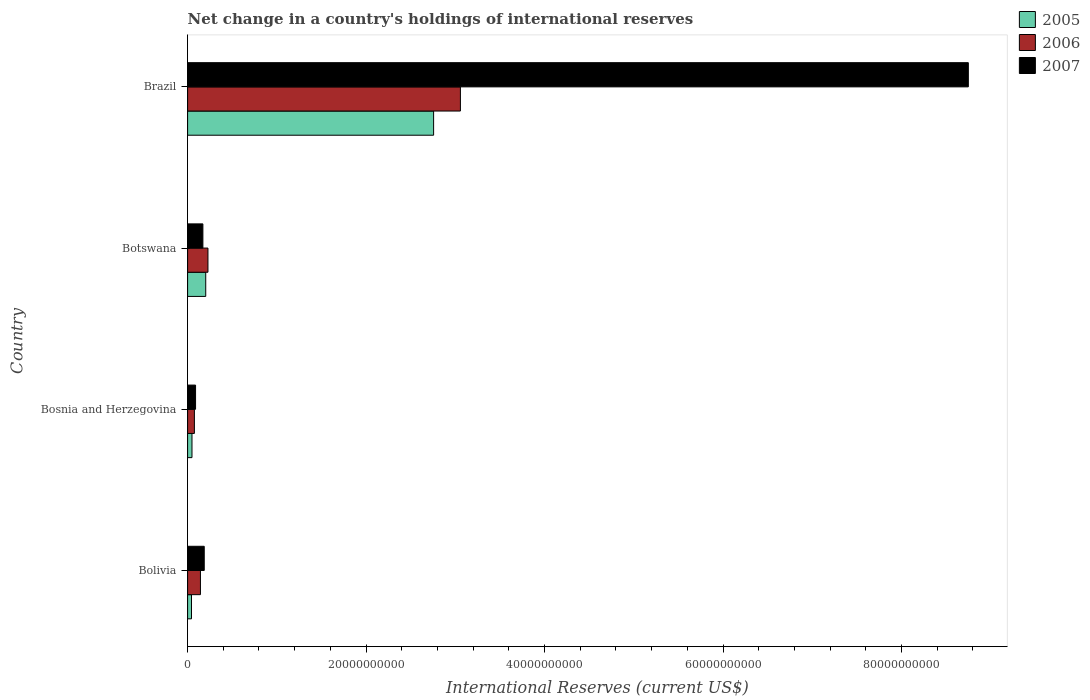How many different coloured bars are there?
Offer a terse response. 3. Are the number of bars per tick equal to the number of legend labels?
Offer a very short reply. Yes. How many bars are there on the 1st tick from the top?
Make the answer very short. 3. How many bars are there on the 2nd tick from the bottom?
Provide a short and direct response. 3. What is the label of the 4th group of bars from the top?
Provide a short and direct response. Bolivia. In how many cases, is the number of bars for a given country not equal to the number of legend labels?
Ensure brevity in your answer.  0. What is the international reserves in 2005 in Bolivia?
Offer a very short reply. 4.37e+08. Across all countries, what is the maximum international reserves in 2005?
Give a very brief answer. 2.76e+1. Across all countries, what is the minimum international reserves in 2006?
Give a very brief answer. 7.61e+08. In which country was the international reserves in 2007 minimum?
Your response must be concise. Bosnia and Herzegovina. What is the total international reserves in 2006 in the graph?
Provide a succinct answer. 3.51e+1. What is the difference between the international reserves in 2006 in Bolivia and that in Brazil?
Ensure brevity in your answer.  -2.91e+1. What is the difference between the international reserves in 2005 in Bolivia and the international reserves in 2007 in Brazil?
Your response must be concise. -8.70e+1. What is the average international reserves in 2007 per country?
Your answer should be very brief. 2.30e+1. What is the difference between the international reserves in 2006 and international reserves in 2007 in Botswana?
Make the answer very short. 5.67e+08. What is the ratio of the international reserves in 2007 in Bolivia to that in Botswana?
Ensure brevity in your answer.  1.09. What is the difference between the highest and the second highest international reserves in 2006?
Offer a very short reply. 2.83e+1. What is the difference between the highest and the lowest international reserves in 2006?
Your answer should be compact. 2.98e+1. In how many countries, is the international reserves in 2005 greater than the average international reserves in 2005 taken over all countries?
Make the answer very short. 1. Is it the case that in every country, the sum of the international reserves in 2005 and international reserves in 2007 is greater than the international reserves in 2006?
Offer a very short reply. Yes. How many bars are there?
Ensure brevity in your answer.  12. Does the graph contain grids?
Provide a succinct answer. No. Where does the legend appear in the graph?
Give a very brief answer. Top right. How many legend labels are there?
Provide a short and direct response. 3. What is the title of the graph?
Offer a very short reply. Net change in a country's holdings of international reserves. Does "2006" appear as one of the legend labels in the graph?
Ensure brevity in your answer.  Yes. What is the label or title of the X-axis?
Offer a very short reply. International Reserves (current US$). What is the International Reserves (current US$) in 2005 in Bolivia?
Keep it short and to the point. 4.37e+08. What is the International Reserves (current US$) in 2006 in Bolivia?
Make the answer very short. 1.44e+09. What is the International Reserves (current US$) of 2007 in Bolivia?
Provide a short and direct response. 1.87e+09. What is the International Reserves (current US$) in 2005 in Bosnia and Herzegovina?
Offer a very short reply. 4.91e+08. What is the International Reserves (current US$) in 2006 in Bosnia and Herzegovina?
Your answer should be very brief. 7.61e+08. What is the International Reserves (current US$) of 2007 in Bosnia and Herzegovina?
Provide a short and direct response. 8.92e+08. What is the International Reserves (current US$) in 2005 in Botswana?
Provide a short and direct response. 2.03e+09. What is the International Reserves (current US$) of 2006 in Botswana?
Give a very brief answer. 2.28e+09. What is the International Reserves (current US$) of 2007 in Botswana?
Keep it short and to the point. 1.71e+09. What is the International Reserves (current US$) of 2005 in Brazil?
Your response must be concise. 2.76e+1. What is the International Reserves (current US$) in 2006 in Brazil?
Offer a very short reply. 3.06e+1. What is the International Reserves (current US$) of 2007 in Brazil?
Keep it short and to the point. 8.75e+1. Across all countries, what is the maximum International Reserves (current US$) of 2005?
Provide a succinct answer. 2.76e+1. Across all countries, what is the maximum International Reserves (current US$) of 2006?
Your answer should be very brief. 3.06e+1. Across all countries, what is the maximum International Reserves (current US$) in 2007?
Ensure brevity in your answer.  8.75e+1. Across all countries, what is the minimum International Reserves (current US$) in 2005?
Provide a succinct answer. 4.37e+08. Across all countries, what is the minimum International Reserves (current US$) of 2006?
Give a very brief answer. 7.61e+08. Across all countries, what is the minimum International Reserves (current US$) in 2007?
Offer a very short reply. 8.92e+08. What is the total International Reserves (current US$) of 2005 in the graph?
Your response must be concise. 3.05e+1. What is the total International Reserves (current US$) of 2006 in the graph?
Your answer should be very brief. 3.51e+1. What is the total International Reserves (current US$) in 2007 in the graph?
Make the answer very short. 9.20e+1. What is the difference between the International Reserves (current US$) in 2005 in Bolivia and that in Bosnia and Herzegovina?
Keep it short and to the point. -5.42e+07. What is the difference between the International Reserves (current US$) of 2006 in Bolivia and that in Bosnia and Herzegovina?
Give a very brief answer. 6.78e+08. What is the difference between the International Reserves (current US$) in 2007 in Bolivia and that in Bosnia and Herzegovina?
Keep it short and to the point. 9.73e+08. What is the difference between the International Reserves (current US$) in 2005 in Bolivia and that in Botswana?
Give a very brief answer. -1.60e+09. What is the difference between the International Reserves (current US$) in 2006 in Bolivia and that in Botswana?
Offer a very short reply. -8.42e+08. What is the difference between the International Reserves (current US$) of 2007 in Bolivia and that in Botswana?
Provide a succinct answer. 1.51e+08. What is the difference between the International Reserves (current US$) in 2005 in Bolivia and that in Brazil?
Provide a succinct answer. -2.71e+1. What is the difference between the International Reserves (current US$) in 2006 in Bolivia and that in Brazil?
Give a very brief answer. -2.91e+1. What is the difference between the International Reserves (current US$) in 2007 in Bolivia and that in Brazil?
Make the answer very short. -8.56e+1. What is the difference between the International Reserves (current US$) of 2005 in Bosnia and Herzegovina and that in Botswana?
Your answer should be compact. -1.54e+09. What is the difference between the International Reserves (current US$) of 2006 in Bosnia and Herzegovina and that in Botswana?
Keep it short and to the point. -1.52e+09. What is the difference between the International Reserves (current US$) in 2007 in Bosnia and Herzegovina and that in Botswana?
Your answer should be compact. -8.22e+08. What is the difference between the International Reserves (current US$) of 2005 in Bosnia and Herzegovina and that in Brazil?
Offer a very short reply. -2.71e+1. What is the difference between the International Reserves (current US$) in 2006 in Bosnia and Herzegovina and that in Brazil?
Ensure brevity in your answer.  -2.98e+1. What is the difference between the International Reserves (current US$) of 2007 in Bosnia and Herzegovina and that in Brazil?
Give a very brief answer. -8.66e+1. What is the difference between the International Reserves (current US$) in 2005 in Botswana and that in Brazil?
Offer a very short reply. -2.55e+1. What is the difference between the International Reserves (current US$) of 2006 in Botswana and that in Brazil?
Offer a very short reply. -2.83e+1. What is the difference between the International Reserves (current US$) in 2007 in Botswana and that in Brazil?
Make the answer very short. -8.58e+1. What is the difference between the International Reserves (current US$) in 2005 in Bolivia and the International Reserves (current US$) in 2006 in Bosnia and Herzegovina?
Offer a very short reply. -3.24e+08. What is the difference between the International Reserves (current US$) in 2005 in Bolivia and the International Reserves (current US$) in 2007 in Bosnia and Herzegovina?
Your answer should be compact. -4.55e+08. What is the difference between the International Reserves (current US$) in 2006 in Bolivia and the International Reserves (current US$) in 2007 in Bosnia and Herzegovina?
Your response must be concise. 5.46e+08. What is the difference between the International Reserves (current US$) in 2005 in Bolivia and the International Reserves (current US$) in 2006 in Botswana?
Provide a short and direct response. -1.84e+09. What is the difference between the International Reserves (current US$) of 2005 in Bolivia and the International Reserves (current US$) of 2007 in Botswana?
Keep it short and to the point. -1.28e+09. What is the difference between the International Reserves (current US$) in 2006 in Bolivia and the International Reserves (current US$) in 2007 in Botswana?
Keep it short and to the point. -2.76e+08. What is the difference between the International Reserves (current US$) in 2005 in Bolivia and the International Reserves (current US$) in 2006 in Brazil?
Make the answer very short. -3.01e+1. What is the difference between the International Reserves (current US$) in 2005 in Bolivia and the International Reserves (current US$) in 2007 in Brazil?
Offer a terse response. -8.70e+1. What is the difference between the International Reserves (current US$) of 2006 in Bolivia and the International Reserves (current US$) of 2007 in Brazil?
Give a very brief answer. -8.60e+1. What is the difference between the International Reserves (current US$) of 2005 in Bosnia and Herzegovina and the International Reserves (current US$) of 2006 in Botswana?
Keep it short and to the point. -1.79e+09. What is the difference between the International Reserves (current US$) in 2005 in Bosnia and Herzegovina and the International Reserves (current US$) in 2007 in Botswana?
Your answer should be compact. -1.22e+09. What is the difference between the International Reserves (current US$) of 2006 in Bosnia and Herzegovina and the International Reserves (current US$) of 2007 in Botswana?
Your answer should be very brief. -9.54e+08. What is the difference between the International Reserves (current US$) of 2005 in Bosnia and Herzegovina and the International Reserves (current US$) of 2006 in Brazil?
Your answer should be compact. -3.01e+1. What is the difference between the International Reserves (current US$) in 2005 in Bosnia and Herzegovina and the International Reserves (current US$) in 2007 in Brazil?
Keep it short and to the point. -8.70e+1. What is the difference between the International Reserves (current US$) of 2006 in Bosnia and Herzegovina and the International Reserves (current US$) of 2007 in Brazil?
Offer a terse response. -8.67e+1. What is the difference between the International Reserves (current US$) in 2005 in Botswana and the International Reserves (current US$) in 2006 in Brazil?
Keep it short and to the point. -2.85e+1. What is the difference between the International Reserves (current US$) of 2005 in Botswana and the International Reserves (current US$) of 2007 in Brazil?
Offer a very short reply. -8.55e+1. What is the difference between the International Reserves (current US$) in 2006 in Botswana and the International Reserves (current US$) in 2007 in Brazil?
Your answer should be very brief. -8.52e+1. What is the average International Reserves (current US$) in 2005 per country?
Ensure brevity in your answer.  7.63e+09. What is the average International Reserves (current US$) of 2006 per country?
Provide a short and direct response. 8.76e+09. What is the average International Reserves (current US$) of 2007 per country?
Provide a short and direct response. 2.30e+1. What is the difference between the International Reserves (current US$) of 2005 and International Reserves (current US$) of 2006 in Bolivia?
Your answer should be compact. -1.00e+09. What is the difference between the International Reserves (current US$) of 2005 and International Reserves (current US$) of 2007 in Bolivia?
Offer a very short reply. -1.43e+09. What is the difference between the International Reserves (current US$) in 2006 and International Reserves (current US$) in 2007 in Bolivia?
Your answer should be very brief. -4.26e+08. What is the difference between the International Reserves (current US$) of 2005 and International Reserves (current US$) of 2006 in Bosnia and Herzegovina?
Offer a very short reply. -2.69e+08. What is the difference between the International Reserves (current US$) in 2005 and International Reserves (current US$) in 2007 in Bosnia and Herzegovina?
Provide a short and direct response. -4.01e+08. What is the difference between the International Reserves (current US$) in 2006 and International Reserves (current US$) in 2007 in Bosnia and Herzegovina?
Your answer should be compact. -1.32e+08. What is the difference between the International Reserves (current US$) in 2005 and International Reserves (current US$) in 2006 in Botswana?
Offer a very short reply. -2.48e+08. What is the difference between the International Reserves (current US$) of 2005 and International Reserves (current US$) of 2007 in Botswana?
Provide a short and direct response. 3.19e+08. What is the difference between the International Reserves (current US$) in 2006 and International Reserves (current US$) in 2007 in Botswana?
Give a very brief answer. 5.67e+08. What is the difference between the International Reserves (current US$) in 2005 and International Reserves (current US$) in 2006 in Brazil?
Your answer should be compact. -3.00e+09. What is the difference between the International Reserves (current US$) of 2005 and International Reserves (current US$) of 2007 in Brazil?
Offer a terse response. -5.99e+1. What is the difference between the International Reserves (current US$) of 2006 and International Reserves (current US$) of 2007 in Brazil?
Provide a short and direct response. -5.69e+1. What is the ratio of the International Reserves (current US$) of 2005 in Bolivia to that in Bosnia and Herzegovina?
Provide a succinct answer. 0.89. What is the ratio of the International Reserves (current US$) of 2006 in Bolivia to that in Bosnia and Herzegovina?
Offer a very short reply. 1.89. What is the ratio of the International Reserves (current US$) in 2007 in Bolivia to that in Bosnia and Herzegovina?
Your answer should be compact. 2.09. What is the ratio of the International Reserves (current US$) of 2005 in Bolivia to that in Botswana?
Keep it short and to the point. 0.22. What is the ratio of the International Reserves (current US$) of 2006 in Bolivia to that in Botswana?
Your answer should be compact. 0.63. What is the ratio of the International Reserves (current US$) in 2007 in Bolivia to that in Botswana?
Offer a terse response. 1.09. What is the ratio of the International Reserves (current US$) of 2005 in Bolivia to that in Brazil?
Your response must be concise. 0.02. What is the ratio of the International Reserves (current US$) in 2006 in Bolivia to that in Brazil?
Give a very brief answer. 0.05. What is the ratio of the International Reserves (current US$) in 2007 in Bolivia to that in Brazil?
Offer a very short reply. 0.02. What is the ratio of the International Reserves (current US$) in 2005 in Bosnia and Herzegovina to that in Botswana?
Make the answer very short. 0.24. What is the ratio of the International Reserves (current US$) in 2006 in Bosnia and Herzegovina to that in Botswana?
Offer a terse response. 0.33. What is the ratio of the International Reserves (current US$) of 2007 in Bosnia and Herzegovina to that in Botswana?
Provide a succinct answer. 0.52. What is the ratio of the International Reserves (current US$) of 2005 in Bosnia and Herzegovina to that in Brazil?
Ensure brevity in your answer.  0.02. What is the ratio of the International Reserves (current US$) in 2006 in Bosnia and Herzegovina to that in Brazil?
Provide a succinct answer. 0.02. What is the ratio of the International Reserves (current US$) of 2007 in Bosnia and Herzegovina to that in Brazil?
Your answer should be very brief. 0.01. What is the ratio of the International Reserves (current US$) in 2005 in Botswana to that in Brazil?
Your response must be concise. 0.07. What is the ratio of the International Reserves (current US$) in 2006 in Botswana to that in Brazil?
Make the answer very short. 0.07. What is the ratio of the International Reserves (current US$) in 2007 in Botswana to that in Brazil?
Keep it short and to the point. 0.02. What is the difference between the highest and the second highest International Reserves (current US$) in 2005?
Keep it short and to the point. 2.55e+1. What is the difference between the highest and the second highest International Reserves (current US$) in 2006?
Your response must be concise. 2.83e+1. What is the difference between the highest and the second highest International Reserves (current US$) of 2007?
Offer a very short reply. 8.56e+1. What is the difference between the highest and the lowest International Reserves (current US$) in 2005?
Provide a short and direct response. 2.71e+1. What is the difference between the highest and the lowest International Reserves (current US$) of 2006?
Your response must be concise. 2.98e+1. What is the difference between the highest and the lowest International Reserves (current US$) in 2007?
Keep it short and to the point. 8.66e+1. 